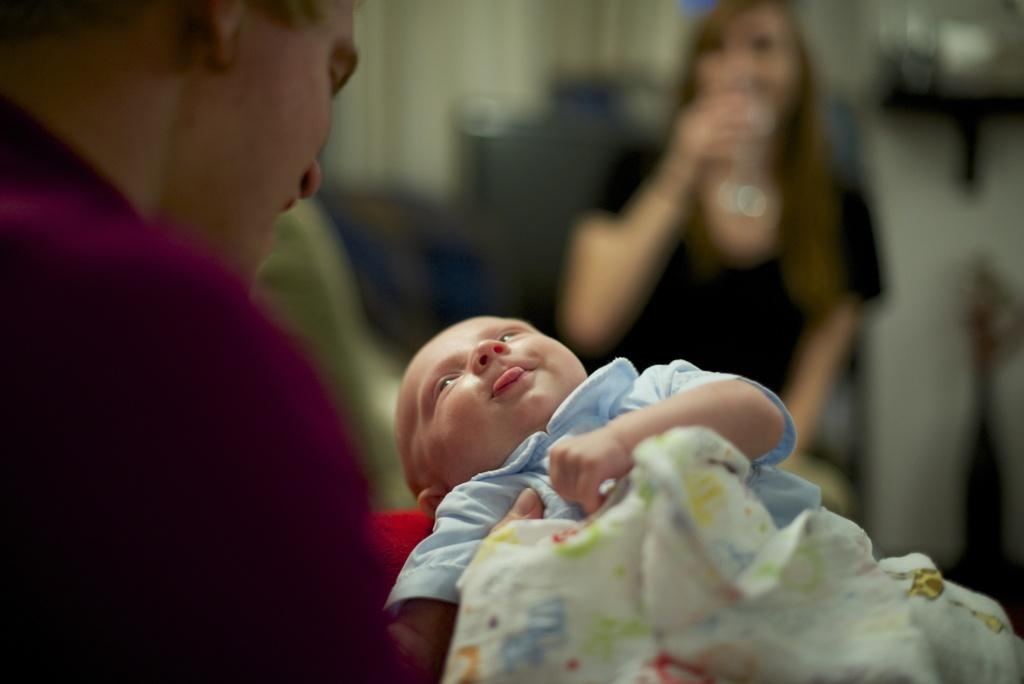Who is the main subject in the image? There is a man in the image. What is the man doing in the image? The man is holding a baby. Is there anyone else in the image besides the man? Yes, there is a woman in front of the man. Can you describe the background of the image? The background of the image is blurry. What type of alarm can be heard going off in the background of the image? There is no alarm present in the image, and therefore no such sound can be heard. 